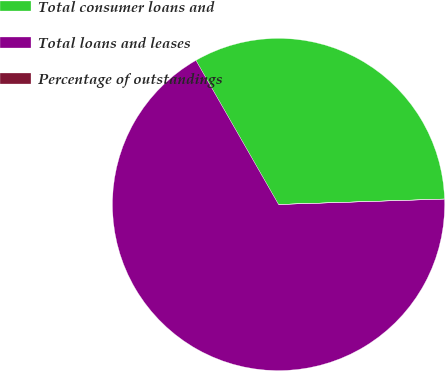Convert chart. <chart><loc_0><loc_0><loc_500><loc_500><pie_chart><fcel>Total consumer loans and<fcel>Total loans and leases<fcel>Percentage of outstandings<nl><fcel>32.76%<fcel>67.23%<fcel>0.01%<nl></chart> 